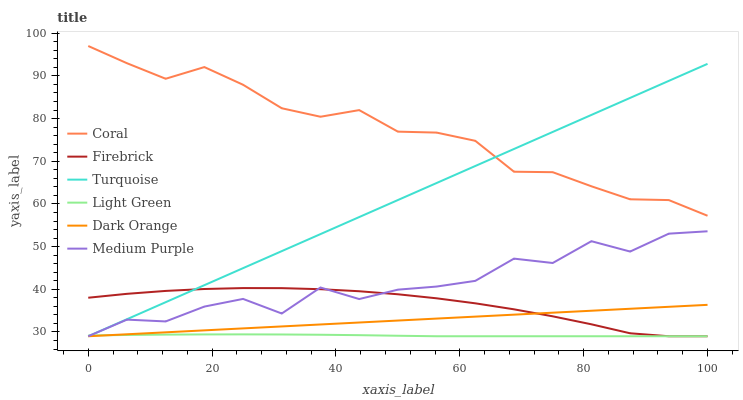Does Light Green have the minimum area under the curve?
Answer yes or no. Yes. Does Coral have the maximum area under the curve?
Answer yes or no. Yes. Does Turquoise have the minimum area under the curve?
Answer yes or no. No. Does Turquoise have the maximum area under the curve?
Answer yes or no. No. Is Dark Orange the smoothest?
Answer yes or no. Yes. Is Medium Purple the roughest?
Answer yes or no. Yes. Is Turquoise the smoothest?
Answer yes or no. No. Is Turquoise the roughest?
Answer yes or no. No. Does Dark Orange have the lowest value?
Answer yes or no. Yes. Does Coral have the lowest value?
Answer yes or no. No. Does Coral have the highest value?
Answer yes or no. Yes. Does Turquoise have the highest value?
Answer yes or no. No. Is Medium Purple less than Coral?
Answer yes or no. Yes. Is Coral greater than Medium Purple?
Answer yes or no. Yes. Does Coral intersect Turquoise?
Answer yes or no. Yes. Is Coral less than Turquoise?
Answer yes or no. No. Is Coral greater than Turquoise?
Answer yes or no. No. Does Medium Purple intersect Coral?
Answer yes or no. No. 